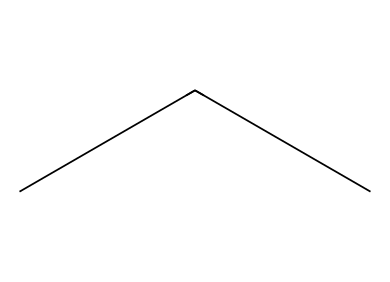what is the chemical name of this compound? The SMILES representation "CCC" corresponds to the molecular structure of propane, which is a three-carbon alkane. Each carbon in propane is bonded to hydrogens to complete their tetravalent nature.
Answer: propane how many carbon atoms are in propane? The SMILES string "CCC" indicates three connected 'C' atoms, which directly shows that there are three carbon atoms in the structure.
Answer: 3 how many hydrogen atoms are in propane? Each carbon atom in propane forms four bonds. In propane, two terminal carbons each bond to three hydrogen atoms and the middle carbon bonds to two, totaling 8 hydrogen atoms (3+2+3).
Answer: 8 what type of bonding is present in propane? Propane consists of single covalent bonds between carbon and hydrogen atoms, characteristic of alkanes, where carbon atoms are connected by sigma bonds and each hydrogen atom is bonded via a single bond.
Answer: covalent is propane considered a greenhouse gas? Although propane is a hydrocarbon, it has a relatively low global warming potential compared to other greenhouse gases like CO2 and methane, but it can still contribute to greenhouse gas effects.
Answer: yes what is the common use of propane as a refrigerant? Propane (R-290) is commonly used in household refrigeration systems due to its eco-friendliness, efficiency in heat exchange, and lower environmental impact compared to traditional refrigerants that contain chlorofluorocarbons (CFCs).
Answer: refrigeration 